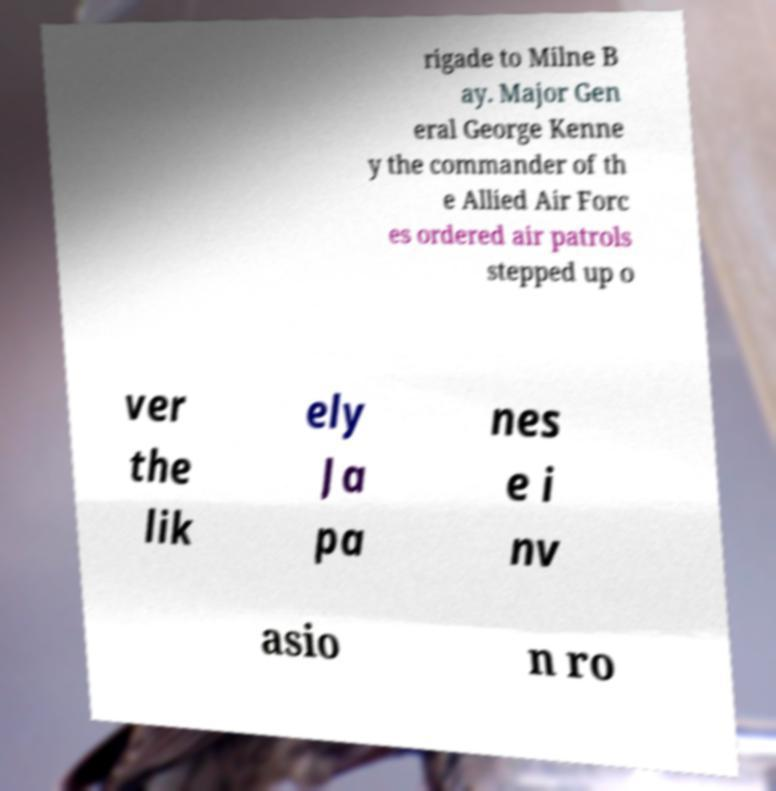What messages or text are displayed in this image? I need them in a readable, typed format. rigade to Milne B ay. Major Gen eral George Kenne y the commander of th e Allied Air Forc es ordered air patrols stepped up o ver the lik ely Ja pa nes e i nv asio n ro 